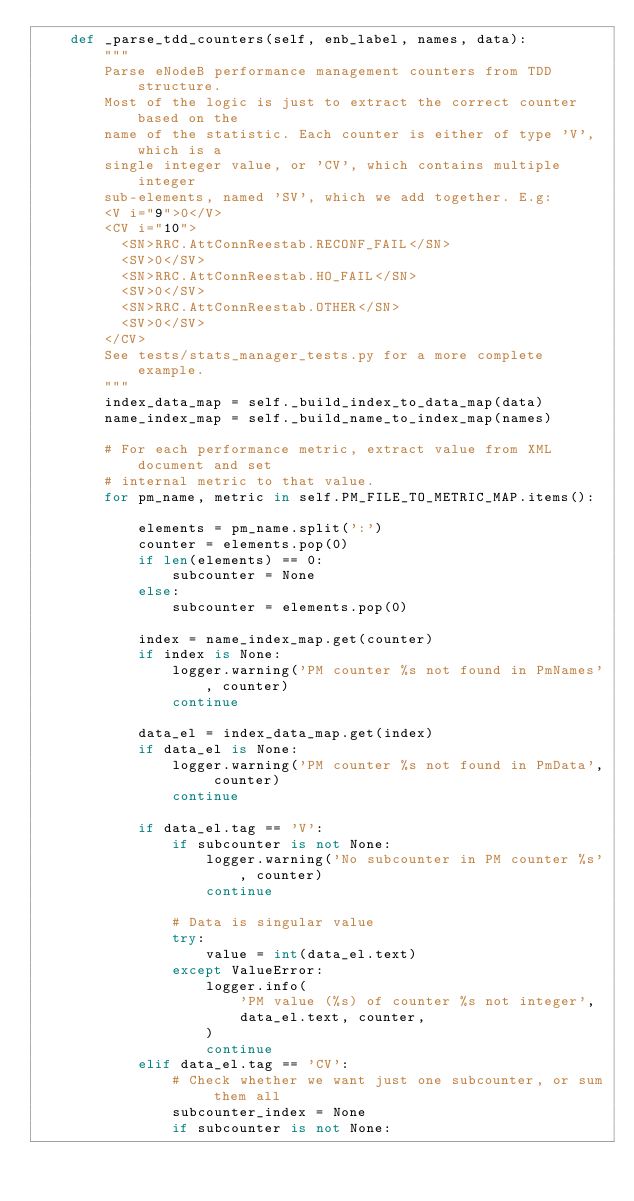Convert code to text. <code><loc_0><loc_0><loc_500><loc_500><_Python_>    def _parse_tdd_counters(self, enb_label, names, data):
        """
        Parse eNodeB performance management counters from TDD structure.
        Most of the logic is just to extract the correct counter based on the
        name of the statistic. Each counter is either of type 'V', which is a
        single integer value, or 'CV', which contains multiple integer
        sub-elements, named 'SV', which we add together. E.g:
        <V i="9">0</V>
        <CV i="10">
          <SN>RRC.AttConnReestab.RECONF_FAIL</SN>
          <SV>0</SV>
          <SN>RRC.AttConnReestab.HO_FAIL</SN>
          <SV>0</SV>
          <SN>RRC.AttConnReestab.OTHER</SN>
          <SV>0</SV>
        </CV>
        See tests/stats_manager_tests.py for a more complete example.
        """
        index_data_map = self._build_index_to_data_map(data)
        name_index_map = self._build_name_to_index_map(names)

        # For each performance metric, extract value from XML document and set
        # internal metric to that value.
        for pm_name, metric in self.PM_FILE_TO_METRIC_MAP.items():

            elements = pm_name.split(':')
            counter = elements.pop(0)
            if len(elements) == 0:
                subcounter = None
            else:
                subcounter = elements.pop(0)

            index = name_index_map.get(counter)
            if index is None:
                logger.warning('PM counter %s not found in PmNames', counter)
                continue

            data_el = index_data_map.get(index)
            if data_el is None:
                logger.warning('PM counter %s not found in PmData', counter)
                continue

            if data_el.tag == 'V':
                if subcounter is not None:
                    logger.warning('No subcounter in PM counter %s', counter)
                    continue

                # Data is singular value
                try:
                    value = int(data_el.text)
                except ValueError:
                    logger.info(
                        'PM value (%s) of counter %s not integer',
                        data_el.text, counter,
                    )
                    continue
            elif data_el.tag == 'CV':
                # Check whether we want just one subcounter, or sum them all
                subcounter_index = None
                if subcounter is not None:</code> 